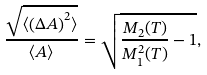Convert formula to latex. <formula><loc_0><loc_0><loc_500><loc_500>\frac { \sqrt { \langle \left ( \Delta A \right ) ^ { 2 } \rangle } } { \langle A \rangle } = \sqrt { \frac { M _ { 2 } ( T ) } { M _ { 1 } ^ { 2 } ( T ) } - 1 } ,</formula> 